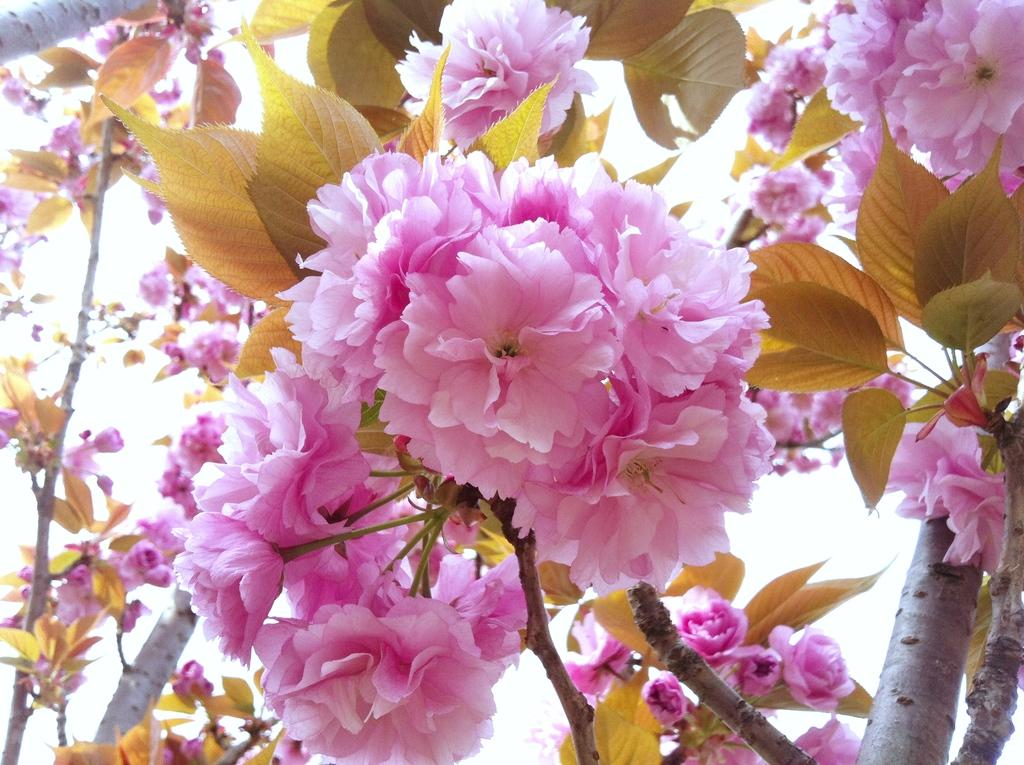What type of plants can be seen in the image? There are flowering plants in the image. What part of the plants is visible in the image? There are leaves in the image. Is there a squirrel using its impulse to exercise its muscle in the image? There is no squirrel or any reference to impulse or muscle in the image; it only features flowering plants and leaves. 